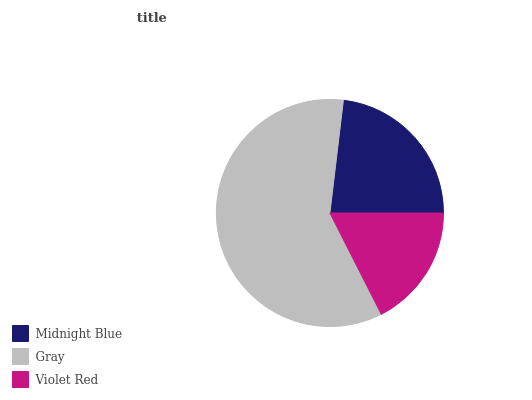Is Violet Red the minimum?
Answer yes or no. Yes. Is Gray the maximum?
Answer yes or no. Yes. Is Gray the minimum?
Answer yes or no. No. Is Violet Red the maximum?
Answer yes or no. No. Is Gray greater than Violet Red?
Answer yes or no. Yes. Is Violet Red less than Gray?
Answer yes or no. Yes. Is Violet Red greater than Gray?
Answer yes or no. No. Is Gray less than Violet Red?
Answer yes or no. No. Is Midnight Blue the high median?
Answer yes or no. Yes. Is Midnight Blue the low median?
Answer yes or no. Yes. Is Violet Red the high median?
Answer yes or no. No. Is Violet Red the low median?
Answer yes or no. No. 